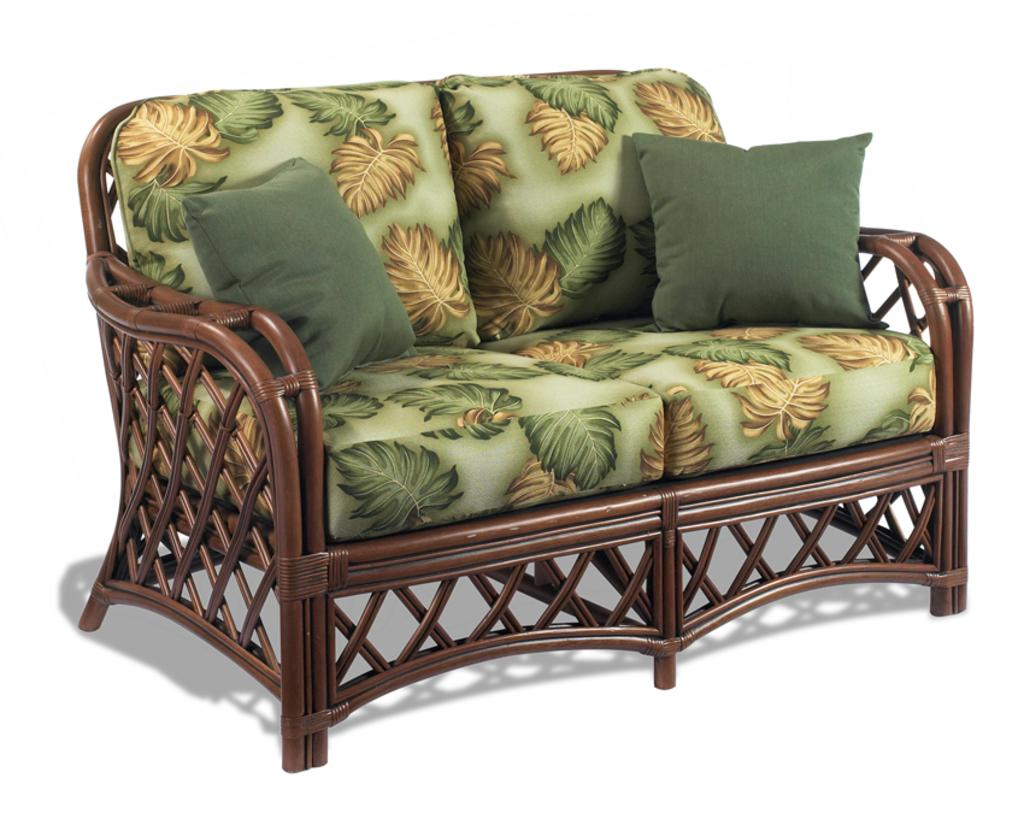What type of furniture is in the image? There is a couch in the image. Are there any accessories on the couch? Yes, there are two pillows on the couch. What color is the background of the image? The background of the image is white. How many cords are hanging from the arm of the couch in the image? There are no cords visible in the image, and the couch does not have an arm. 